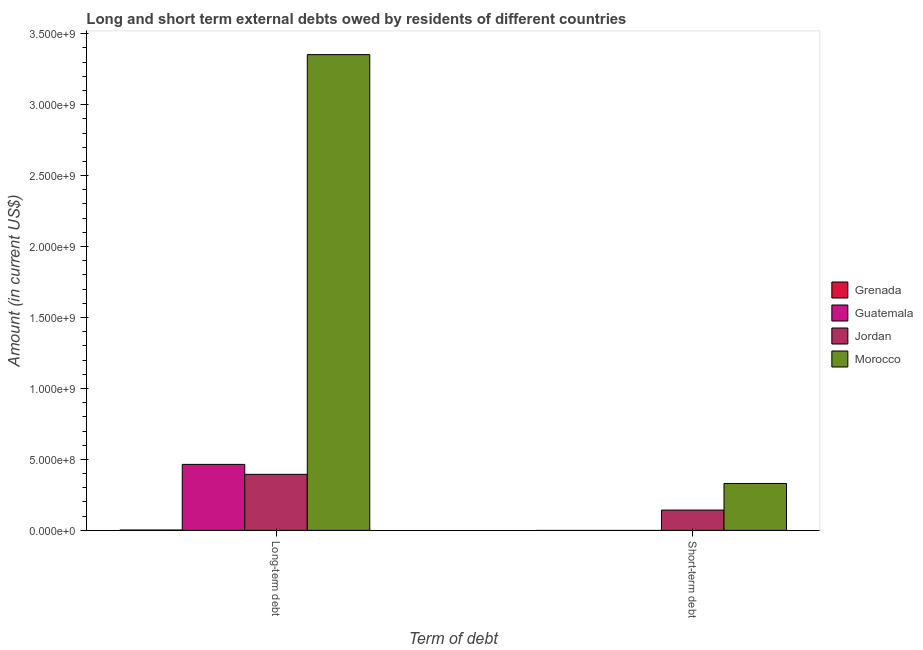Are the number of bars per tick equal to the number of legend labels?
Offer a terse response. No. How many bars are there on the 2nd tick from the right?
Your answer should be very brief. 4. What is the label of the 1st group of bars from the left?
Your response must be concise. Long-term debt. What is the short-term debts owed by residents in Morocco?
Offer a terse response. 3.30e+08. Across all countries, what is the maximum short-term debts owed by residents?
Your response must be concise. 3.30e+08. Across all countries, what is the minimum long-term debts owed by residents?
Keep it short and to the point. 2.42e+06. In which country was the long-term debts owed by residents maximum?
Offer a very short reply. Morocco. What is the total long-term debts owed by residents in the graph?
Keep it short and to the point. 4.21e+09. What is the difference between the long-term debts owed by residents in Grenada and that in Morocco?
Your answer should be very brief. -3.35e+09. What is the difference between the long-term debts owed by residents in Jordan and the short-term debts owed by residents in Morocco?
Offer a very short reply. 6.44e+07. What is the average long-term debts owed by residents per country?
Ensure brevity in your answer.  1.05e+09. What is the difference between the short-term debts owed by residents and long-term debts owed by residents in Morocco?
Provide a short and direct response. -3.02e+09. What is the ratio of the short-term debts owed by residents in Morocco to that in Jordan?
Give a very brief answer. 2.31. In how many countries, is the short-term debts owed by residents greater than the average short-term debts owed by residents taken over all countries?
Offer a terse response. 2. How many countries are there in the graph?
Ensure brevity in your answer.  4. Are the values on the major ticks of Y-axis written in scientific E-notation?
Keep it short and to the point. Yes. Does the graph contain any zero values?
Your response must be concise. Yes. Does the graph contain grids?
Give a very brief answer. No. Where does the legend appear in the graph?
Your response must be concise. Center right. How are the legend labels stacked?
Your answer should be compact. Vertical. What is the title of the graph?
Give a very brief answer. Long and short term external debts owed by residents of different countries. What is the label or title of the X-axis?
Offer a terse response. Term of debt. What is the label or title of the Y-axis?
Give a very brief answer. Amount (in current US$). What is the Amount (in current US$) in Grenada in Long-term debt?
Offer a terse response. 2.42e+06. What is the Amount (in current US$) of Guatemala in Long-term debt?
Make the answer very short. 4.65e+08. What is the Amount (in current US$) in Jordan in Long-term debt?
Give a very brief answer. 3.95e+08. What is the Amount (in current US$) of Morocco in Long-term debt?
Your response must be concise. 3.35e+09. What is the Amount (in current US$) of Guatemala in Short-term debt?
Offer a terse response. 0. What is the Amount (in current US$) in Jordan in Short-term debt?
Provide a succinct answer. 1.43e+08. What is the Amount (in current US$) in Morocco in Short-term debt?
Give a very brief answer. 3.30e+08. Across all Term of debt, what is the maximum Amount (in current US$) in Grenada?
Offer a terse response. 2.42e+06. Across all Term of debt, what is the maximum Amount (in current US$) in Guatemala?
Your answer should be compact. 4.65e+08. Across all Term of debt, what is the maximum Amount (in current US$) in Jordan?
Keep it short and to the point. 3.95e+08. Across all Term of debt, what is the maximum Amount (in current US$) of Morocco?
Your response must be concise. 3.35e+09. Across all Term of debt, what is the minimum Amount (in current US$) in Guatemala?
Your answer should be very brief. 0. Across all Term of debt, what is the minimum Amount (in current US$) of Jordan?
Your answer should be very brief. 1.43e+08. Across all Term of debt, what is the minimum Amount (in current US$) of Morocco?
Make the answer very short. 3.30e+08. What is the total Amount (in current US$) in Grenada in the graph?
Your response must be concise. 2.42e+06. What is the total Amount (in current US$) in Guatemala in the graph?
Offer a terse response. 4.65e+08. What is the total Amount (in current US$) of Jordan in the graph?
Keep it short and to the point. 5.38e+08. What is the total Amount (in current US$) of Morocco in the graph?
Offer a terse response. 3.68e+09. What is the difference between the Amount (in current US$) in Jordan in Long-term debt and that in Short-term debt?
Your response must be concise. 2.52e+08. What is the difference between the Amount (in current US$) of Morocco in Long-term debt and that in Short-term debt?
Give a very brief answer. 3.02e+09. What is the difference between the Amount (in current US$) in Grenada in Long-term debt and the Amount (in current US$) in Jordan in Short-term debt?
Keep it short and to the point. -1.41e+08. What is the difference between the Amount (in current US$) in Grenada in Long-term debt and the Amount (in current US$) in Morocco in Short-term debt?
Make the answer very short. -3.28e+08. What is the difference between the Amount (in current US$) of Guatemala in Long-term debt and the Amount (in current US$) of Jordan in Short-term debt?
Make the answer very short. 3.22e+08. What is the difference between the Amount (in current US$) of Guatemala in Long-term debt and the Amount (in current US$) of Morocco in Short-term debt?
Offer a very short reply. 1.35e+08. What is the difference between the Amount (in current US$) in Jordan in Long-term debt and the Amount (in current US$) in Morocco in Short-term debt?
Make the answer very short. 6.44e+07. What is the average Amount (in current US$) of Grenada per Term of debt?
Offer a very short reply. 1.21e+06. What is the average Amount (in current US$) in Guatemala per Term of debt?
Ensure brevity in your answer.  2.33e+08. What is the average Amount (in current US$) in Jordan per Term of debt?
Your answer should be compact. 2.69e+08. What is the average Amount (in current US$) of Morocco per Term of debt?
Your response must be concise. 1.84e+09. What is the difference between the Amount (in current US$) of Grenada and Amount (in current US$) of Guatemala in Long-term debt?
Offer a very short reply. -4.63e+08. What is the difference between the Amount (in current US$) in Grenada and Amount (in current US$) in Jordan in Long-term debt?
Your answer should be compact. -3.92e+08. What is the difference between the Amount (in current US$) of Grenada and Amount (in current US$) of Morocco in Long-term debt?
Keep it short and to the point. -3.35e+09. What is the difference between the Amount (in current US$) in Guatemala and Amount (in current US$) in Jordan in Long-term debt?
Your response must be concise. 7.02e+07. What is the difference between the Amount (in current US$) of Guatemala and Amount (in current US$) of Morocco in Long-term debt?
Offer a terse response. -2.89e+09. What is the difference between the Amount (in current US$) of Jordan and Amount (in current US$) of Morocco in Long-term debt?
Your answer should be very brief. -2.96e+09. What is the difference between the Amount (in current US$) in Jordan and Amount (in current US$) in Morocco in Short-term debt?
Your response must be concise. -1.87e+08. What is the ratio of the Amount (in current US$) of Jordan in Long-term debt to that in Short-term debt?
Give a very brief answer. 2.76. What is the ratio of the Amount (in current US$) of Morocco in Long-term debt to that in Short-term debt?
Provide a succinct answer. 10.14. What is the difference between the highest and the second highest Amount (in current US$) of Jordan?
Ensure brevity in your answer.  2.52e+08. What is the difference between the highest and the second highest Amount (in current US$) in Morocco?
Your answer should be very brief. 3.02e+09. What is the difference between the highest and the lowest Amount (in current US$) of Grenada?
Your answer should be compact. 2.42e+06. What is the difference between the highest and the lowest Amount (in current US$) of Guatemala?
Offer a very short reply. 4.65e+08. What is the difference between the highest and the lowest Amount (in current US$) in Jordan?
Make the answer very short. 2.52e+08. What is the difference between the highest and the lowest Amount (in current US$) in Morocco?
Make the answer very short. 3.02e+09. 